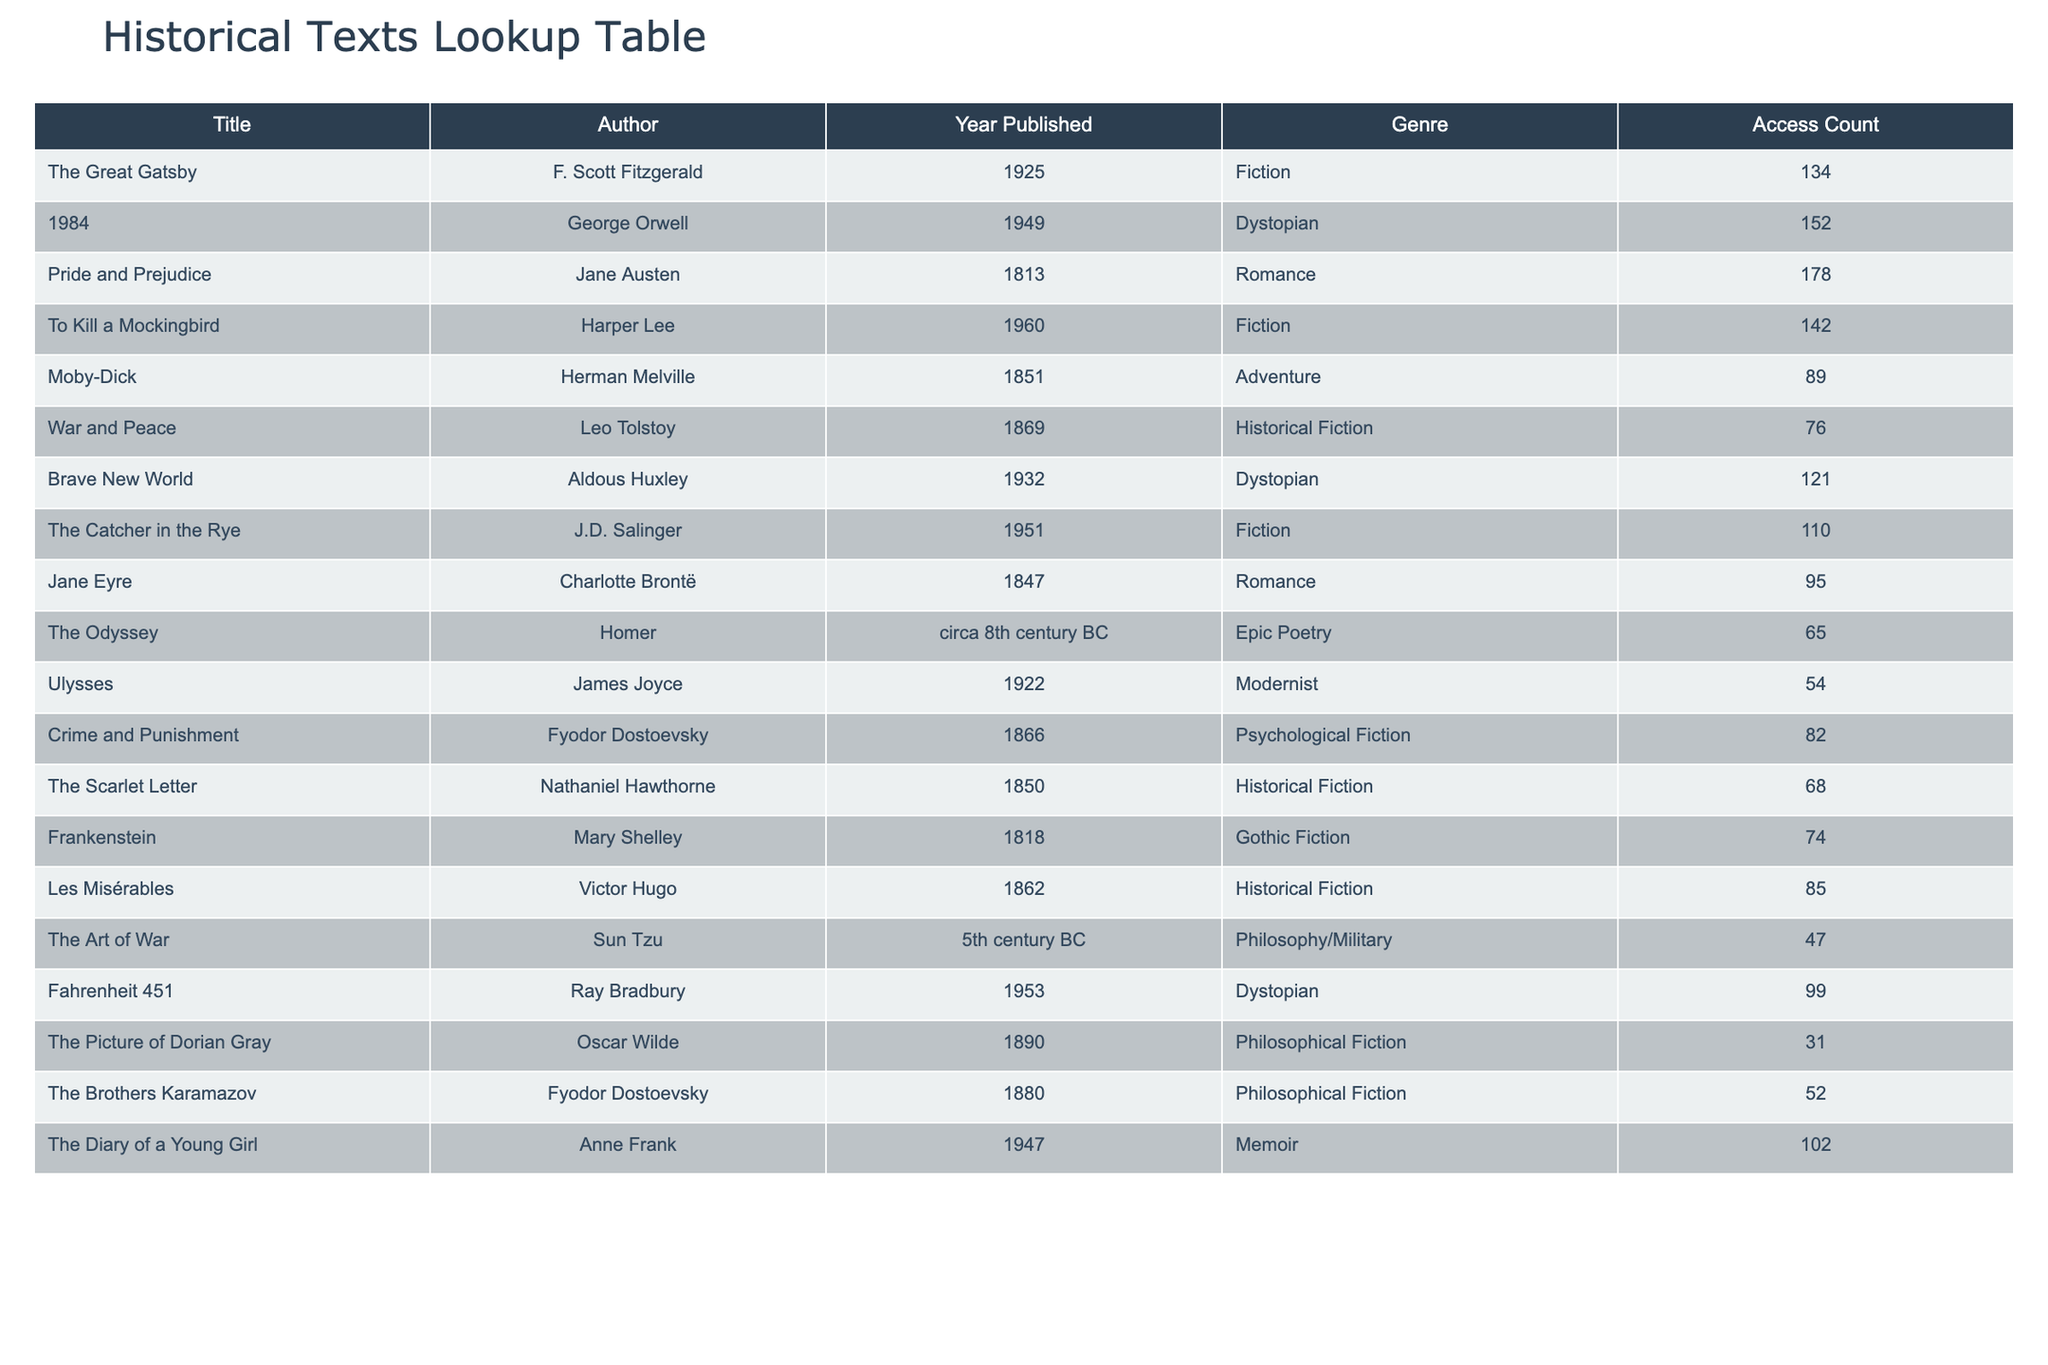What is the title of the most accessed historical text? The table lists the access counts for each book, and we can see that "Pride and Prejudice" has the highest access count among the historical texts with a count of 178.
Answer: Pride and Prejudice How many times was "1984" accessed? Looking at the access count column directly, "1984" was accessed 152 times.
Answer: 152 Which text has the lowest access count? By examining the access counts, we find that "The Picture of Dorian Gray" has the lowest access count at 31.
Answer: The Picture of Dorian Gray What is the total access count for all historical fiction texts? The total access count for historical fiction is calculated by summing the counts of "War and Peace" (76), "The Scarlet Letter" (68), and "Les Misérables" (85). The total is 76 + 68 + 85 = 229.
Answer: 229 Did "The Odyssey" have more access than "Frankenstein"? Comparing the access counts, "The Odyssey" had 65 accesses and "Frankenstein" had 74. Since 65 is less than 74, the statement is false.
Answer: No What is the average access count for the romance genre texts? To find the average for romance, we take "Pride and Prejudice" (178) and "Jane Eyre" (95). Their sum is 178 + 95 = 273. Since there are two texts, the average is 273/2 = 136.5.
Answer: 136.5 Which author has the most accessed text? By checking the access counts, "Pride and Prejudice" by Jane Austen has the highest count at 178, making her the author of the most accessed text.
Answer: Jane Austen Is "Brave New World" more accessed than "To Kill a Mockingbird"? "Brave New World" has 121 accesses while "To Kill a Mockingbird" has 142. Since 121 is less than 142, the statement is false.
Answer: No What is the difference in access counts between "The Great Gatsby" and "Fahrenheit 451"? We subtract the access count of "Fahrenheit 451" (99) from "The Great Gatsby" (134). The difference is 134 - 99 = 35.
Answer: 35 